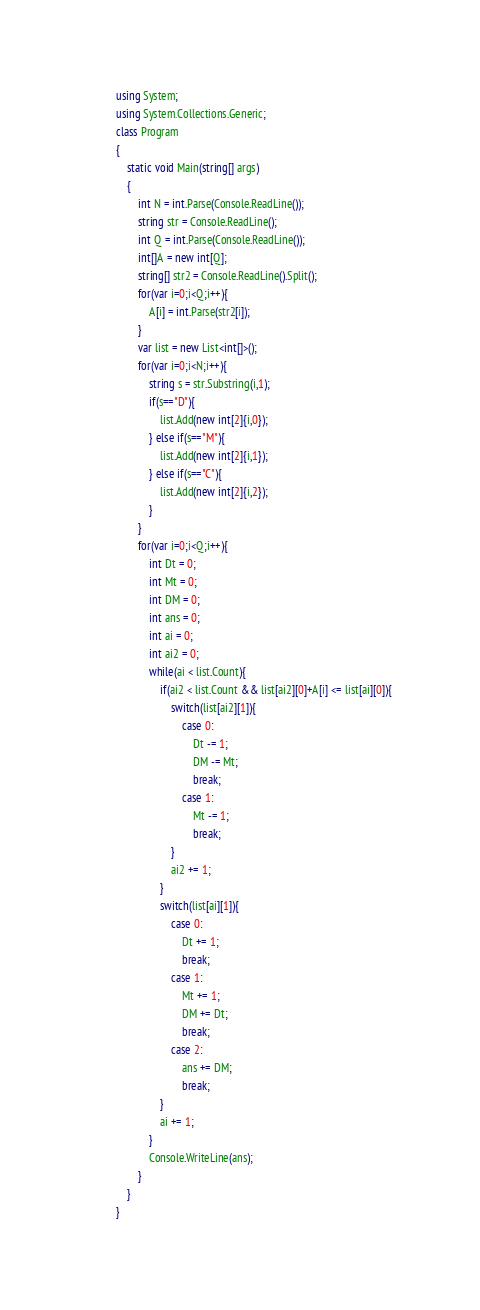Convert code to text. <code><loc_0><loc_0><loc_500><loc_500><_C#_>using System;
using System.Collections.Generic;
class Program
{
	static void Main(string[] args)
	{
		int N = int.Parse(Console.ReadLine());
		string str = Console.ReadLine();
		int Q = int.Parse(Console.ReadLine());
		int[]A = new int[Q];
		string[] str2 = Console.ReadLine().Split();
		for(var i=0;i<Q;i++){
			A[i] = int.Parse(str2[i]);
		}
		var list = new List<int[]>();
		for(var i=0;i<N;i++){
			string s = str.Substring(i,1);
			if(s=="D"){
				list.Add(new int[2]{i,0});
			} else if(s=="M"){
				list.Add(new int[2]{i,1});
			} else if(s=="C"){
				list.Add(new int[2]{i,2});
			}
		}
		for(var i=0;i<Q;i++){
			int Dt = 0;
			int Mt = 0;
			int DM = 0;
			int ans = 0;
			int ai = 0;
			int ai2 = 0;
			while(ai < list.Count){
				if(ai2 < list.Count && list[ai2][0]+A[i] <= list[ai][0]){
					switch(list[ai2][1]){
						case 0:
							Dt -= 1;
							DM -= Mt;
							break;
						case 1:
							Mt -= 1;
							break;
					}
					ai2 += 1;
				}
				switch(list[ai][1]){
					case 0:
						Dt += 1;
						break;
					case 1:
						Mt += 1;
						DM += Dt;
						break;
					case 2:
						ans += DM;
						break;
				}
				ai += 1;
			}
			Console.WriteLine(ans);
		}
	}
}</code> 